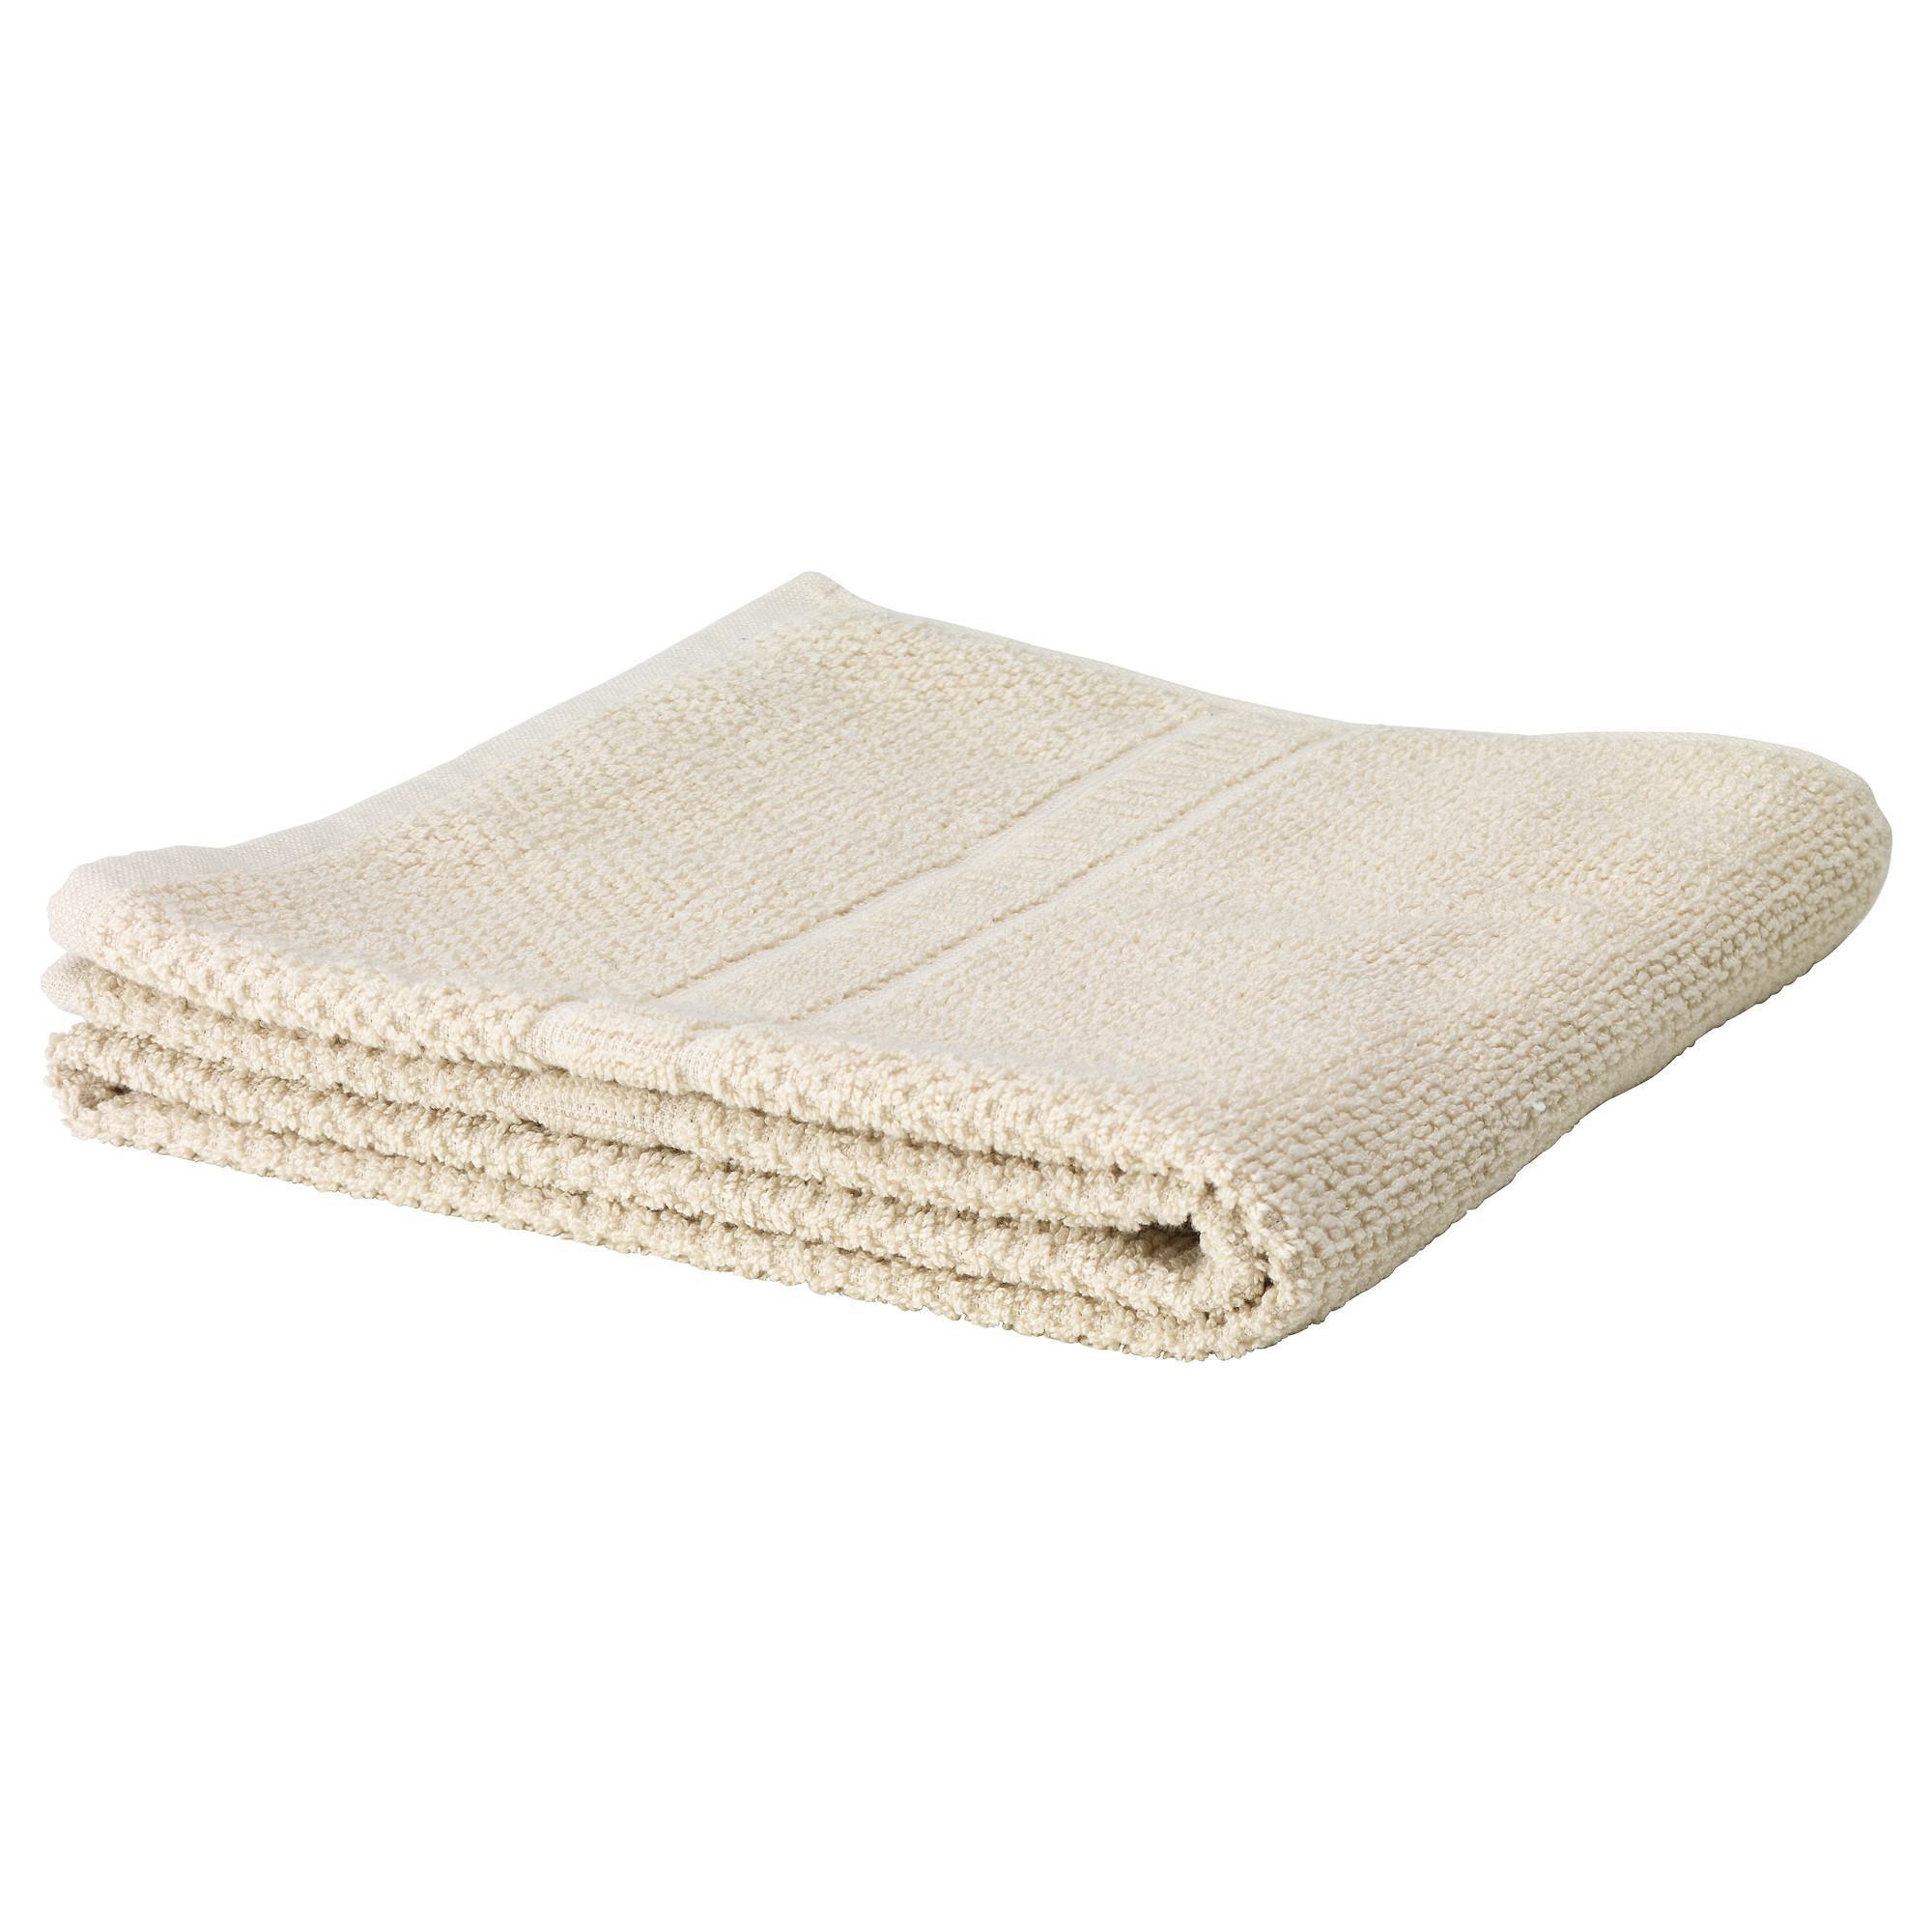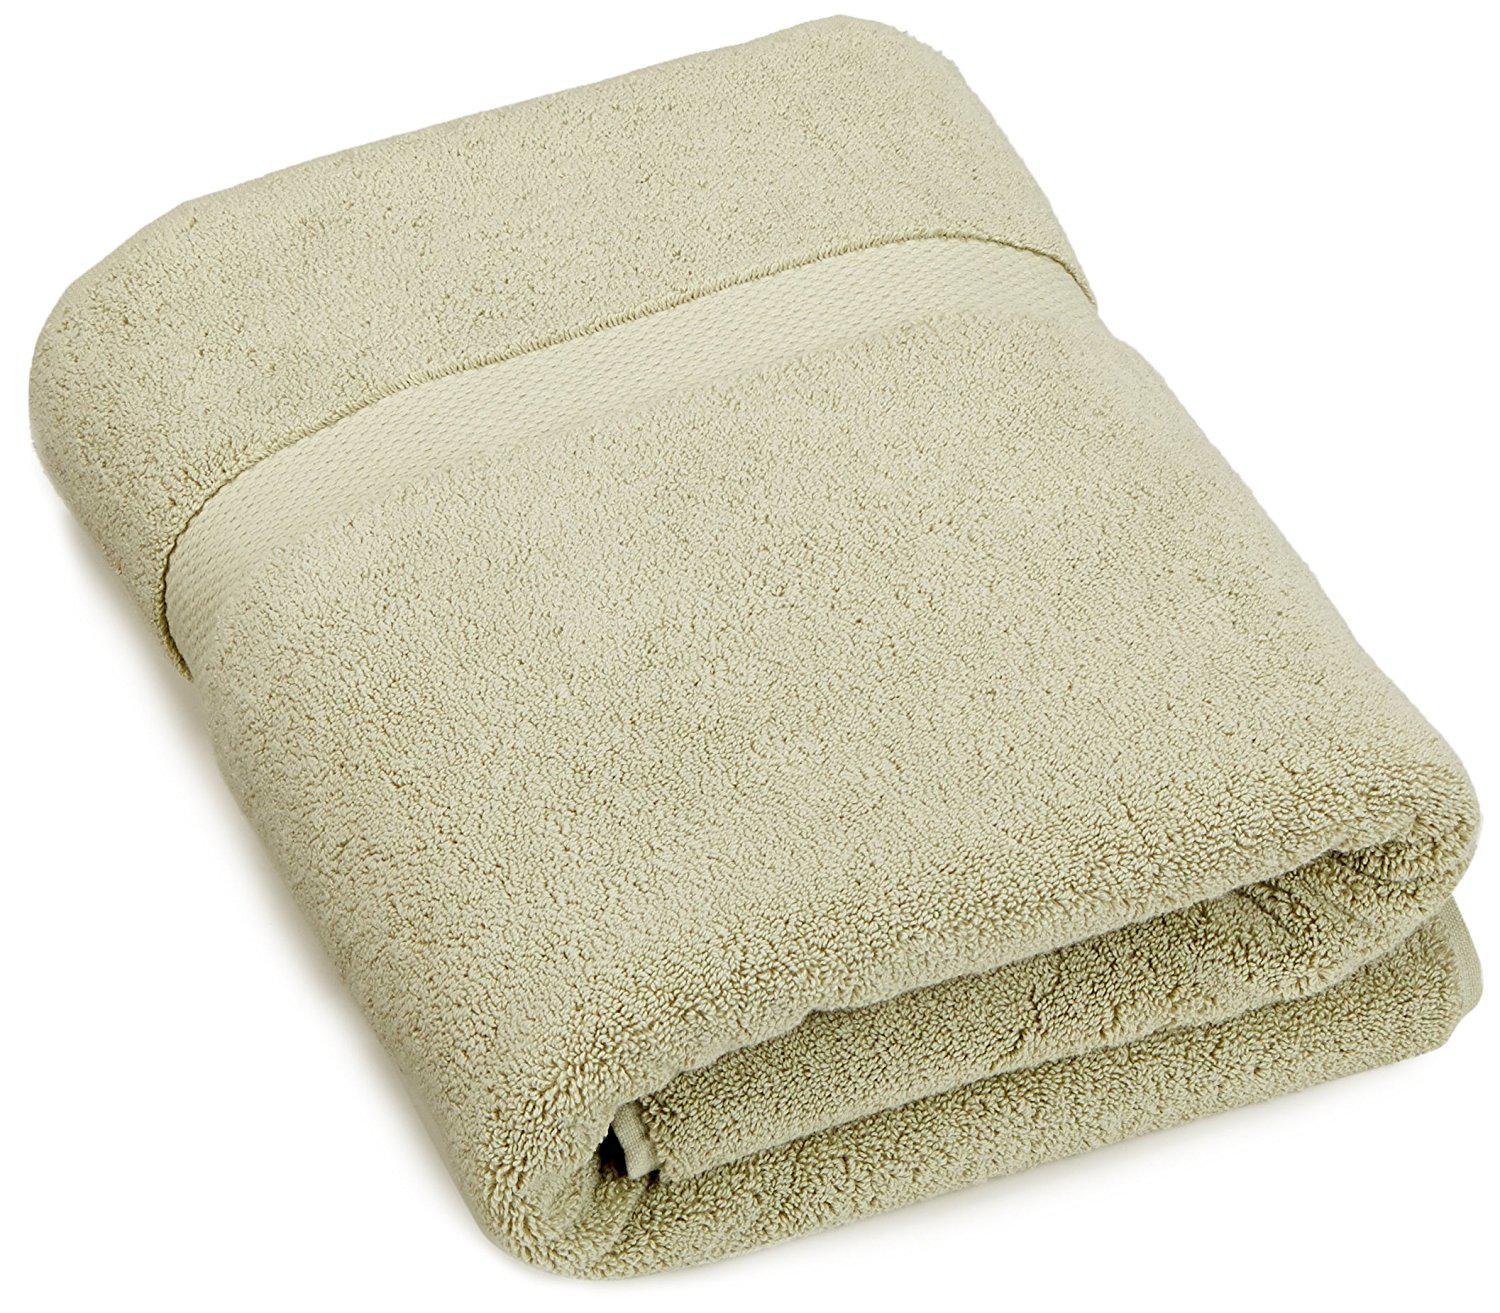The first image is the image on the left, the second image is the image on the right. Examine the images to the left and right. Is the description "There is no less than six towels." accurate? Answer yes or no. No. The first image is the image on the left, the second image is the image on the right. Analyze the images presented: Is the assertion "There are exactly two towels." valid? Answer yes or no. Yes. 